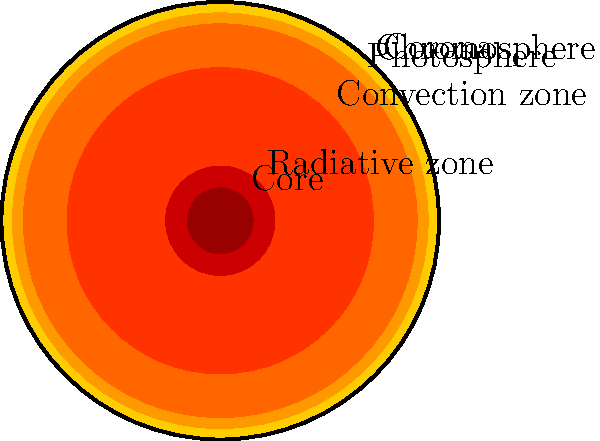Dans cette illustration en coupe du Soleil, quelle couche est responsable de la production d'énergie par fusion nucléaire ? (In this cutaway illustration of the Sun, which layer is responsible for energy production through nuclear fusion?) Let's analyze the layers of the Sun from the inside out:

1. Core: This is the innermost layer of the Sun. It's where nuclear fusion occurs, converting hydrogen into helium and releasing enormous amounts of energy.

2. Radiative zone: This layer surrounds the core. Energy from the core travels through this region via radiation.

3. Convection zone: Above the radiative zone, energy is transferred by convection currents.

4. Photosphere: This is the visible surface of the Sun.

5. Chromosphere: A thin layer above the photosphere, visible during solar eclipses.

6. Corona: The outermost layer of the Sun's atmosphere, extending far into space.

The core is where nuclear fusion takes place, generating the Sun's energy. This process occurs at extremely high temperatures (about 15 million degrees Celsius) and pressures. The energy produced here then travels outward through the other layers before eventually reaching us on Earth.
Answer: Le noyau (The core) 